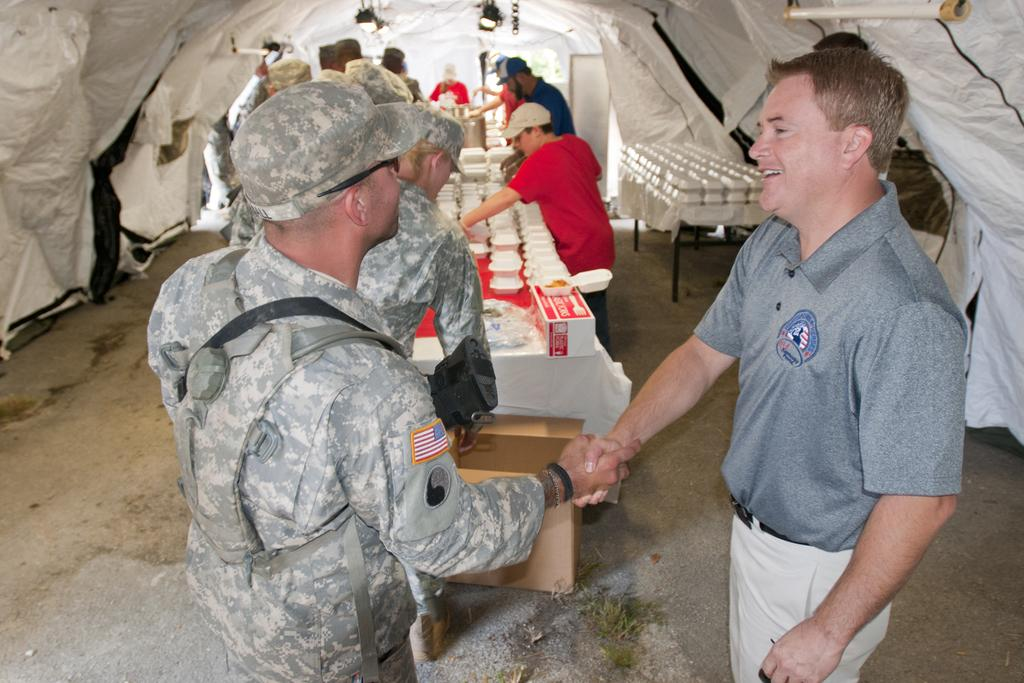How many people are in the image? There are two people in the image. What are the two people doing? The two people are shaking hands and looking at each other. What can be seen in the background of the image? There is a table in the background of the image. What is on the table in the background? There are items on the table in the background. Can you describe the people in the tent? There are people looking at the items on the table in a tent. What type of hat is the squirrel wearing in the image? There is no squirrel present in the image, and therefore no hat can be observed. 